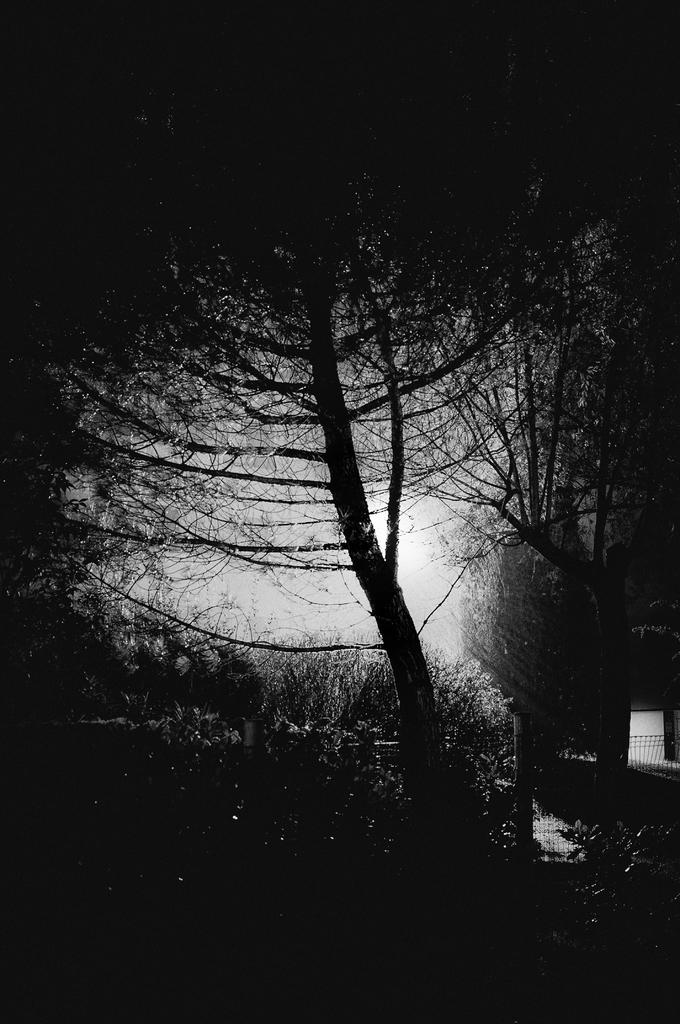What is the color scheme of the image? The image is black and white. What type of natural elements can be seen in the image? There are trees with branches and leaves in the image. What can be inferred about these trees? These trees are likely plants. What architectural feature is present on the right side of the image? There are iron grilles on the right side of the image. How many eggs are visible in the image? There are no eggs present in the image. What type of shame is depicted in the image? There is no shame depicted in the image; it features trees, branches, leaves, and iron grilles. 